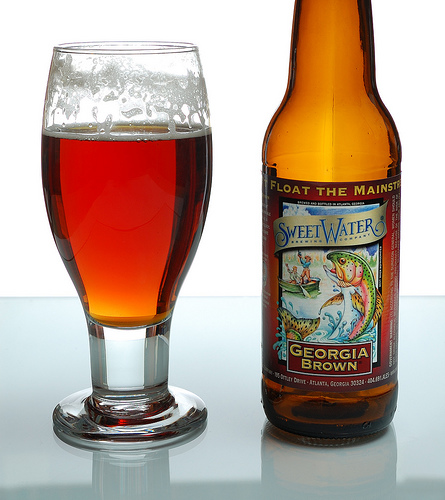<image>
Is there a table under the glass? Yes. The table is positioned underneath the glass, with the glass above it in the vertical space. 